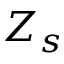Convert formula to latex. <formula><loc_0><loc_0><loc_500><loc_500>Z _ { s }</formula> 